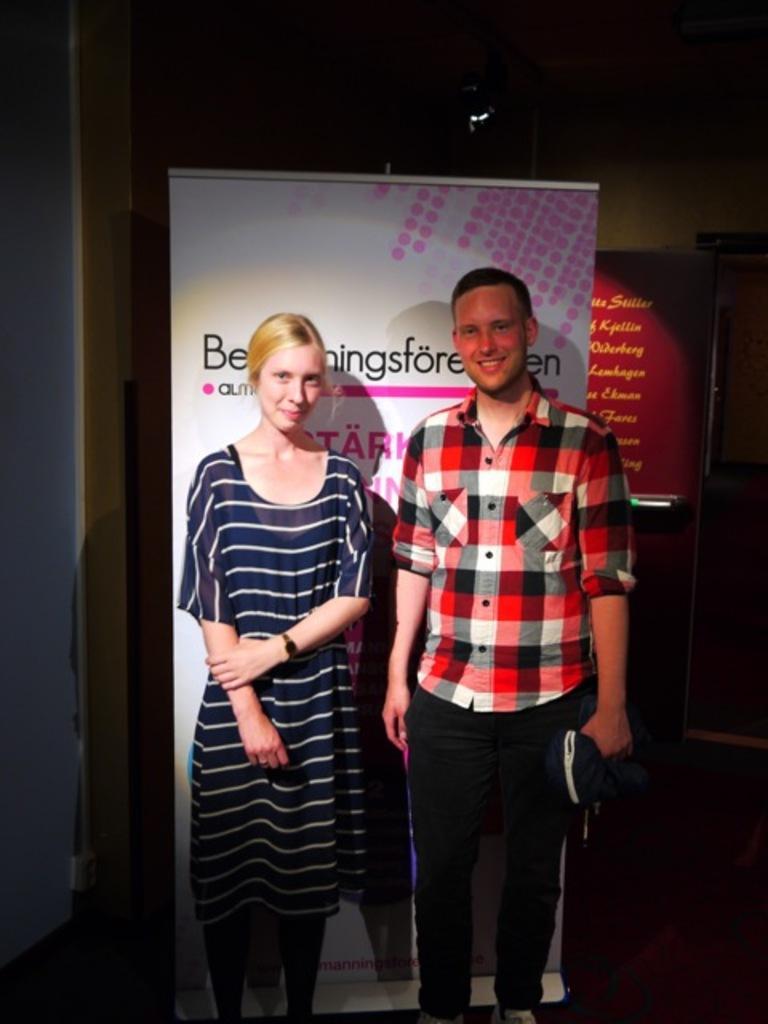How would you summarize this image in a sentence or two? In this picture there is a man wearing red and black check shirt, standing and smiling. Beside there a woman wearing blue color top, standing and giving a pose into the camera. Behind there is a white and pink color roller banner. 